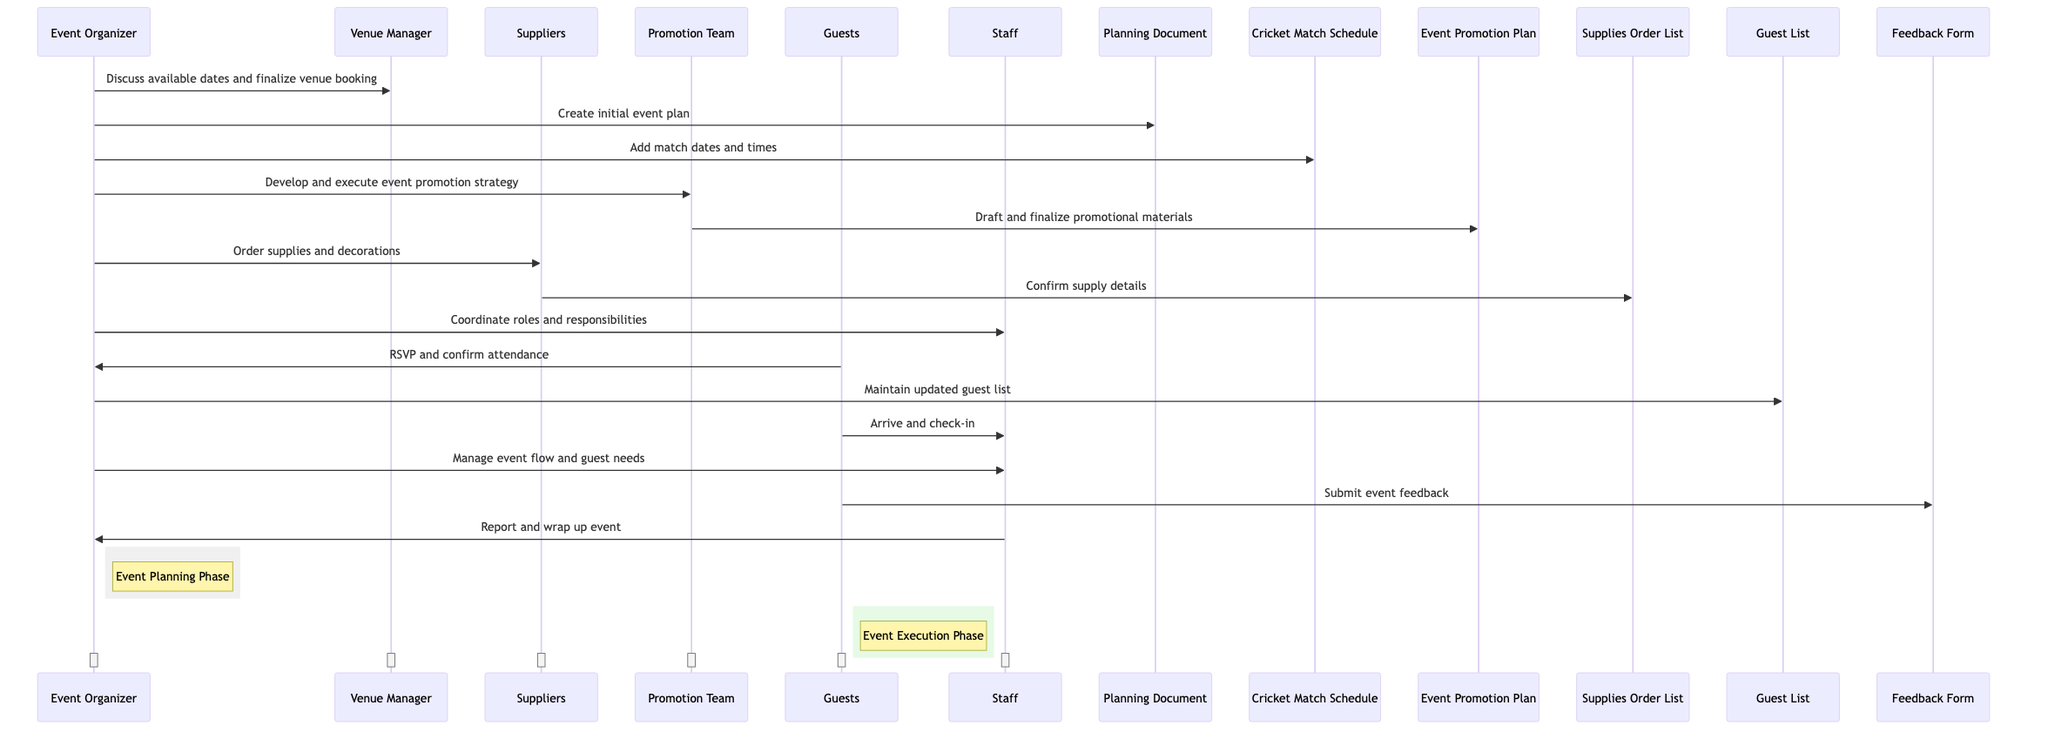What is the first action taken by the Event Organizer? The first action taken by the Event Organizer is to discuss available dates and finalize venue booking with the Venue Manager. This is indicated as the first message in the sequence diagram.
Answer: Discuss available dates and finalize venue booking How many actors are involved in the sequence diagram? The diagram includes six actors: Event Organizer, Venue Manager, Suppliers, Promotion Team, Guests, and Staff. This can be counted from the 'actors' section of the data.
Answer: Six Which object is maintained by the Event Organizer? The Event Organizer maintains the updated Guest List, as shown in the message directed towards the Guest List in the diagram.
Answer: Guest List What phase follows after Event Planning Phase? The phase that follows the Event Planning Phase is the Event Execution Phase, which is indicated by the rectangular annotation next to the Guests.
Answer: Event Execution Phase How does the Promotion Team contribute to event preparation? The Promotion Team contributes by drafting and finalizing promotional materials, which is evidenced by the message sent to the Event Promotion Plan.
Answer: Draft and finalize promotional materials What is the last action depicted in the sequence diagram? The last action depicted is the Staff reporting and wrapping up the event to the Event Organizer, occurring at the end of the event sequence.
Answer: Report and wrap up event What message is exchanged between Guests and Staff? The message exchanged is that Guests arrive and check-in with the Staff, as indicated in the diagram.
Answer: Arrive and check-in Which two objects do the Event Organizer and Guests interact with? The Event Organizer interacts with the Guest List, while Guests interact with the Feedback Form, as shown by the messages directed towards each object.
Answer: Guest List and Feedback Form 